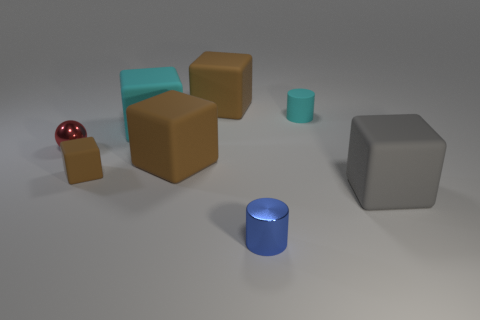What number of objects are objects that are in front of the small red shiny thing or brown rubber things right of the tiny matte block? In the image, there is one small red shiny sphere, and to the right of the tiny matte block, which is grey, there are three brown objects. Considering only the objects that are either in front of the red sphere or to the right of the grey block, we have four distinct objects fulfilling the criteria. 